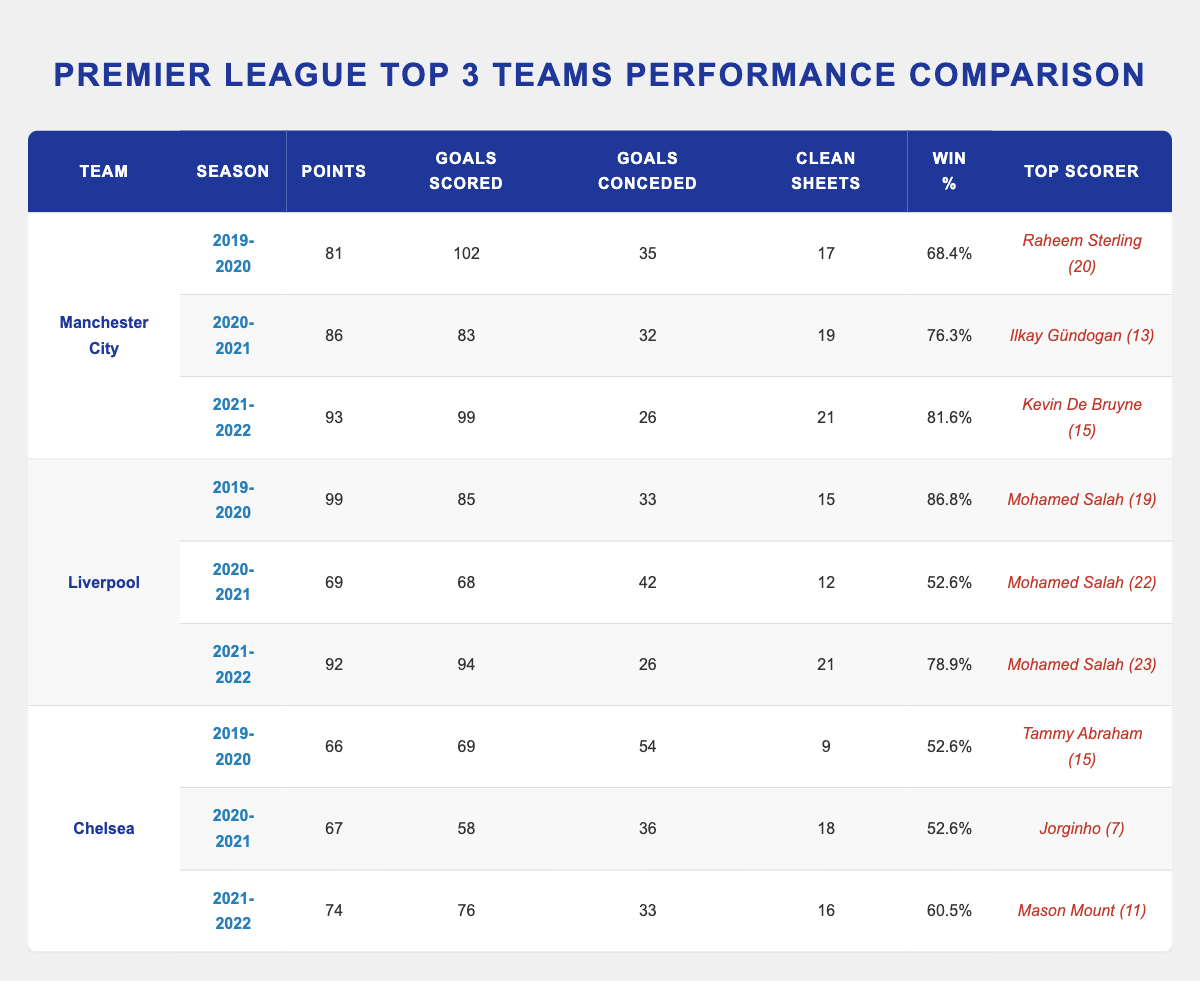What team had the highest points total in the 2019-2020 season? The table shows that Liverpool had 99 points in the 2019-2020 season, while Manchester City had 81 points and Chelsea had 66 points. Thus, Liverpool had the highest points total.
Answer: Liverpool What was the top scorer for Manchester City in the 2020-2021 season? According to the table, Ilkay Gündogan was the top scorer for Manchester City in the 2020-2021 season, with 13 goals.
Answer: Ilkay Gündogan (13) Which team had the highest win percentage in the 2021-2022 season? In the 2021-2022 season, Manchester City had a win percentage of 81.6%, Liverpool had 78.9%, and Chelsea had 60.5%. Therefore, Manchester City had the highest win percentage.
Answer: Manchester City What is the average goals scored by Chelsea over the three seasons? Chelsea scored 69 goals in 2019-2020, 58 in 2020-2021, and 76 in 2021-2022. The average is (69 + 58 + 76) / 3 = 203 / 3 = 67.67, rounded to 68.
Answer: 68 Did Liverpool have more clean sheets in the 2021-2022 season compared to the 2020-2021 season? Liverpool had 21 clean sheets in the 2021-2022 season and 12 in the 2020-2021 season. Since 21 is greater than 12, the statement is true.
Answer: Yes Which team's win percentage improved the most from the 2019-2020 season to the 2021-2022 season? Manchester City had an increase from 68.4% to 81.6% (a change of 13.2%). Liverpool went from 86.8% to 78.9% (a decrease of 7.9%), and Chelsea from 52.6% to 60.5% (an increase of 7.9%). Thus, Manchester City showed the most improvement.
Answer: Manchester City What was the total goals conceded by Liverpool across all three seasons? Liverpool conceded 33 goals in 2019-2020, 42 in 2020-2021, and 26 in 2021-2022. The total goals conceded is 33 + 42 + 26 = 101.
Answer: 101 Who was Chelsea's top scorer in the 2019-2020 season? The table indicates that Chelsea's top scorer in the 2019-2020 season was Tammy Abraham, with 15 goals.
Answer: Tammy Abraham (15) Which team consistently had a higher points total than Chelsea for all three seasons? By reviewing the points totals, Manchester City had 81, 86, and 93 points across the three seasons, and Liverpool had 99, 69, and 92 points. Both teams had more points than Chelsea in each season (66, 67, and 74, respectively). Thus, both Manchester City and Liverpool consistently outperformed Chelsea.
Answer: Manchester City and Liverpool 